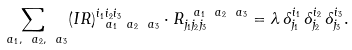<formula> <loc_0><loc_0><loc_500><loc_500>\sum _ { \ a _ { 1 } , \ a _ { 2 } , \ a _ { 3 } } ( I R ) _ { \ a _ { 1 } \ a _ { 2 } \ a _ { 3 } } ^ { i _ { 1 } i _ { 2 } i _ { 3 } } \cdot R ^ { \ a _ { 1 } \ a _ { 2 } \ a _ { 3 } } _ { j _ { 1 } j _ { 2 } j _ { 3 } } = \lambda \, \delta ^ { i _ { 1 } } _ { j _ { 1 } } \, \delta ^ { i _ { 2 } } _ { j _ { 2 } } \, \delta ^ { i _ { 3 } } _ { j _ { 3 } } .</formula> 